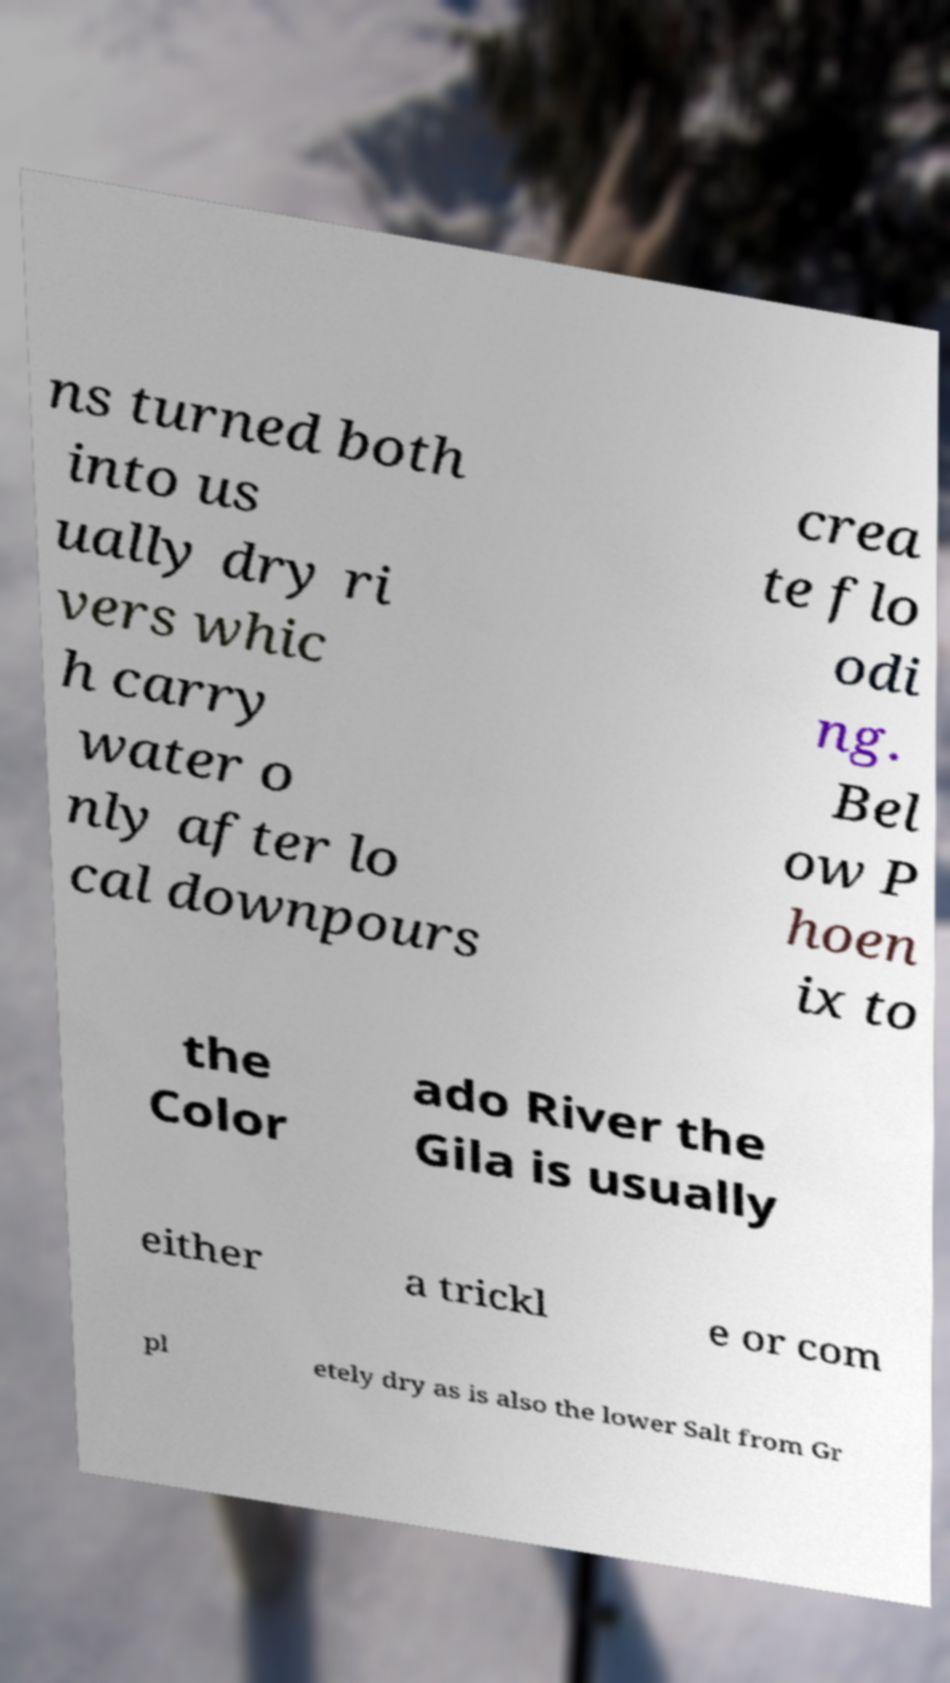Could you extract and type out the text from this image? ns turned both into us ually dry ri vers whic h carry water o nly after lo cal downpours crea te flo odi ng. Bel ow P hoen ix to the Color ado River the Gila is usually either a trickl e or com pl etely dry as is also the lower Salt from Gr 